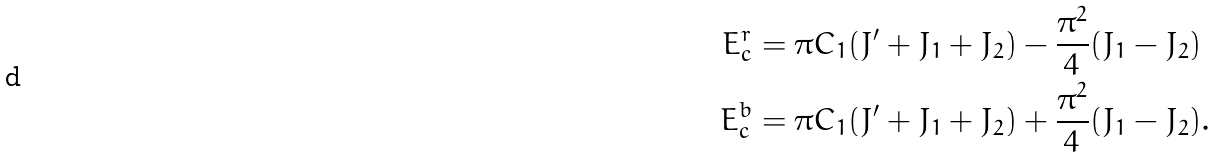<formula> <loc_0><loc_0><loc_500><loc_500>E _ { c } ^ { r } & = \pi C _ { 1 } ( J ^ { \prime } + J _ { 1 } + J _ { 2 } ) - \frac { \pi ^ { 2 } } { 4 } ( J _ { 1 } - J _ { 2 } ) \\ E _ { c } ^ { b } & = \pi C _ { 1 } ( J ^ { \prime } + J _ { 1 } + J _ { 2 } ) + \frac { \pi ^ { 2 } } { 4 } ( J _ { 1 } - J _ { 2 } ) .</formula> 